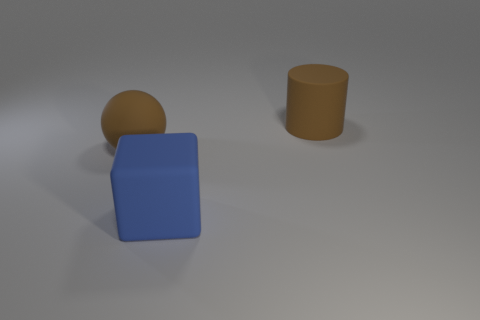Add 3 tiny metallic cylinders. How many objects exist? 6 Subtract all cubes. How many objects are left? 2 Subtract 0 purple cylinders. How many objects are left? 3 Subtract all blue matte things. Subtract all rubber cylinders. How many objects are left? 1 Add 1 big blue rubber blocks. How many big blue rubber blocks are left? 2 Add 2 cylinders. How many cylinders exist? 3 